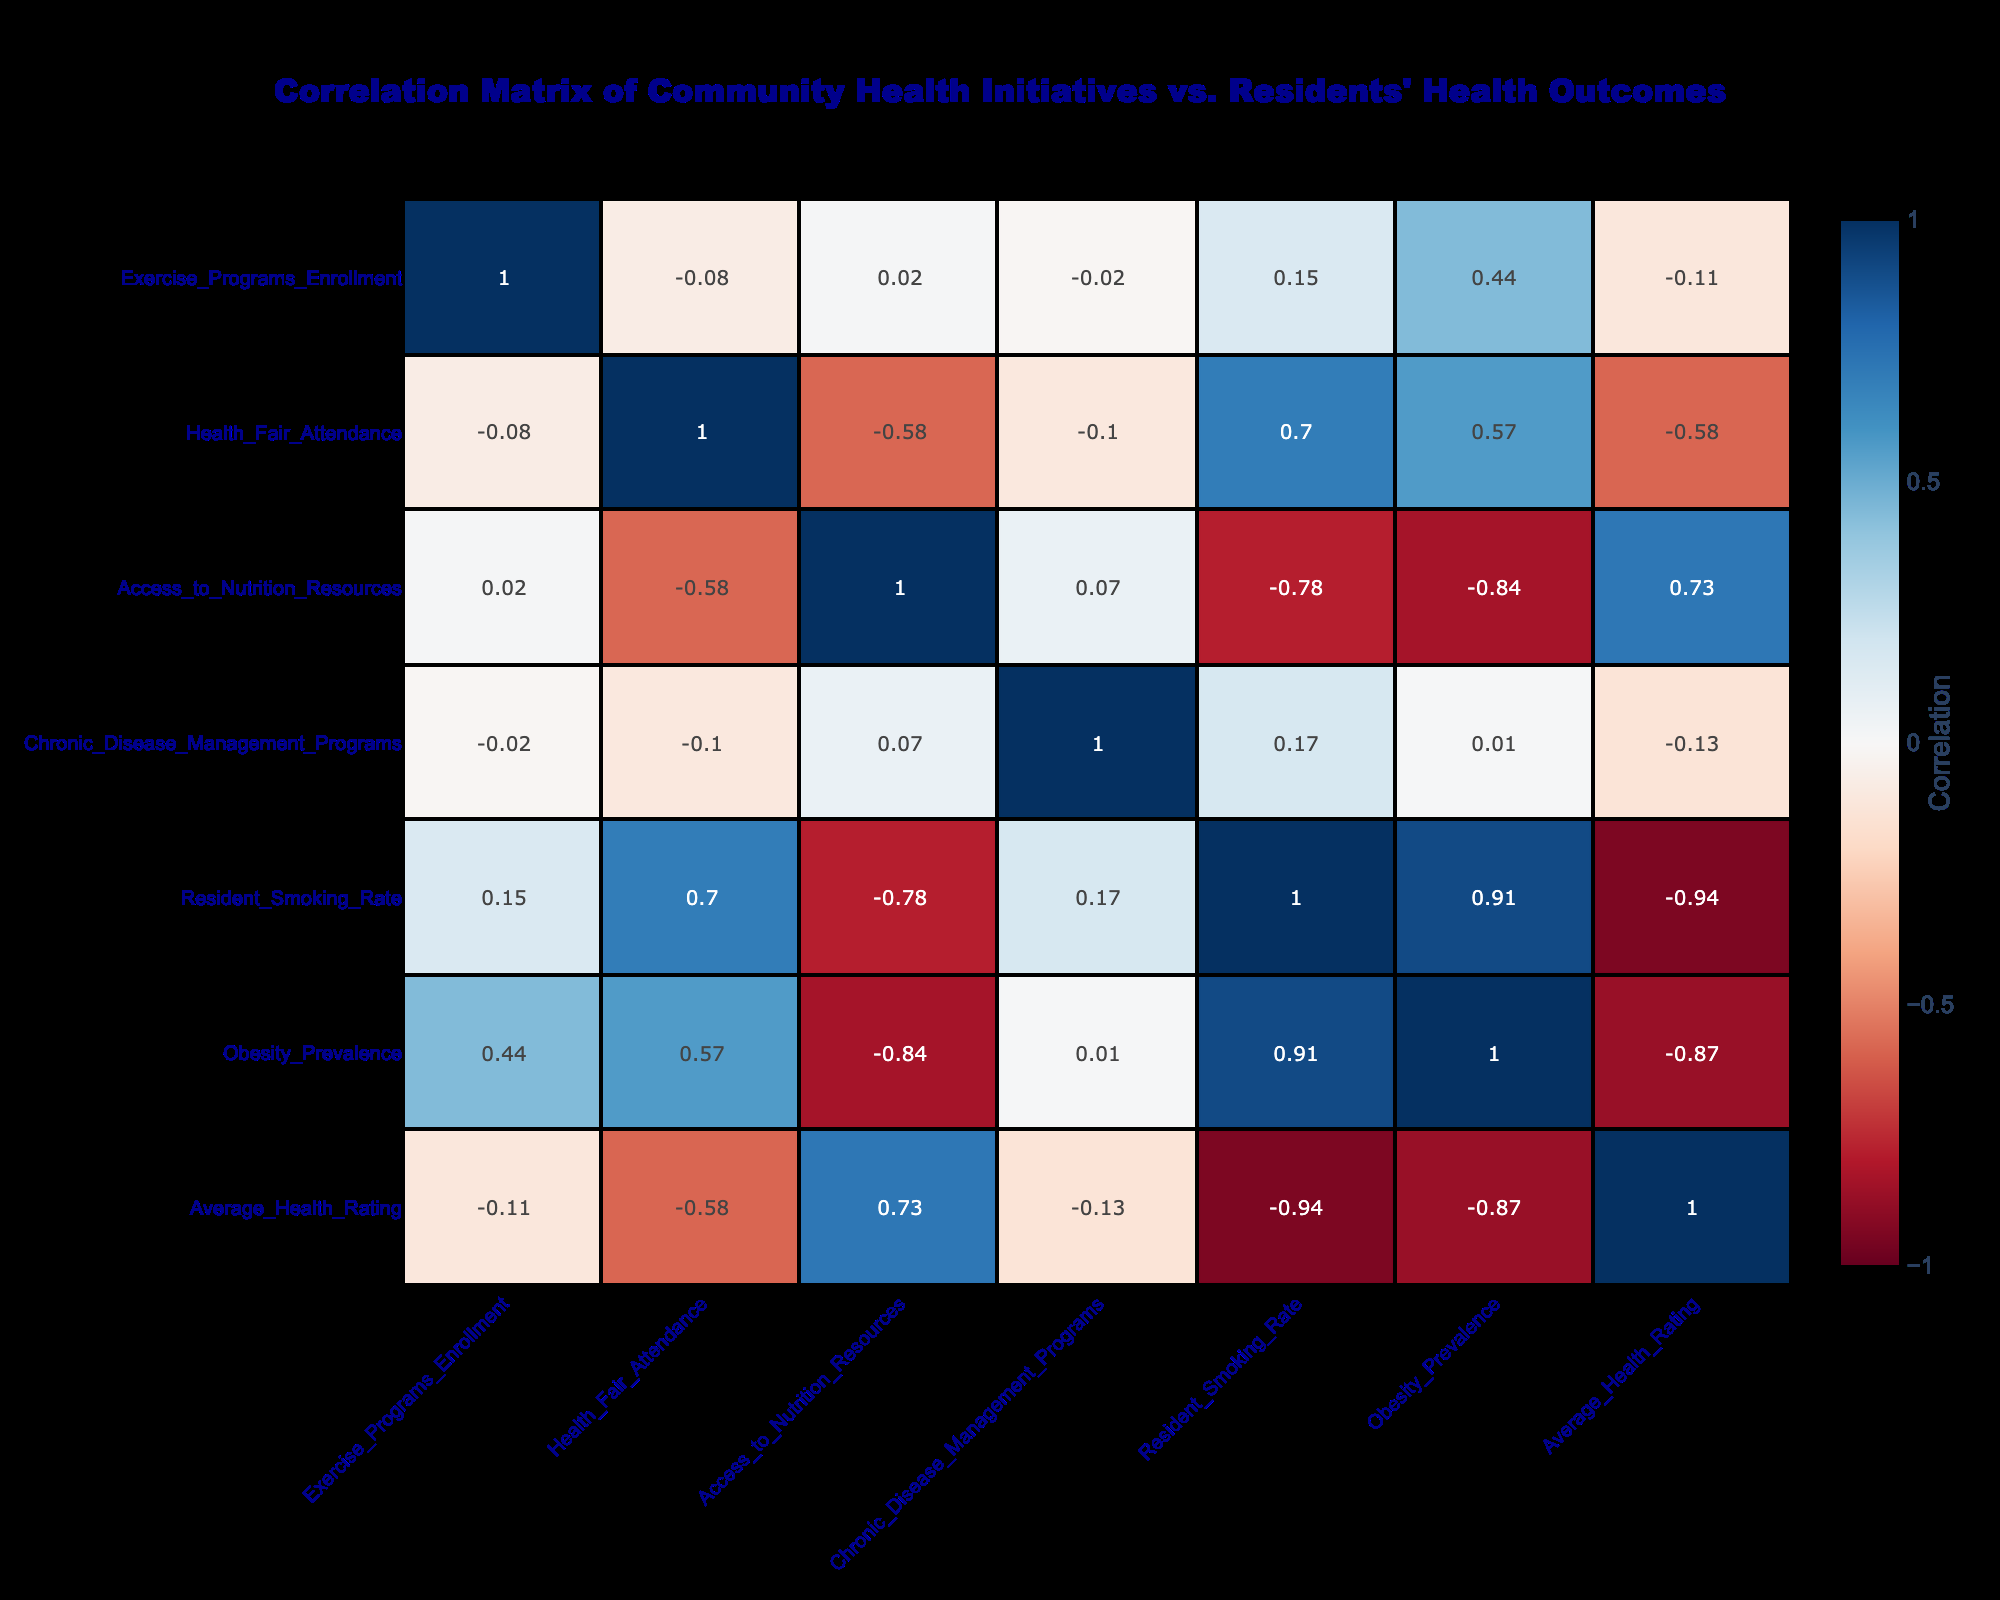What is the correlation between the Smoking Cessation Programs and the Resident Smoking Rate? Looking at the correlation table, the correlation coefficient between Smoking Cessation Programs and Resident Smoking Rate is -0.80, indicating a strong inverse relationship; as participation in cessation programs increases, the smoking rate tends to decrease.
Answer: -0.80 Which initiative correlates most positively with residents' average health rating? First, I will look through the correlation values relating to Average Health Rating. The initiative with the highest positive correlation (0.88) is the Smoking Cessation Programs, indicating that higher enrollment in these programs is associated with better average health ratings among residents.
Answer: Smoking Cessation Programs Are there any community health initiatives with a negative correlation with Obesity Prevalence? The table shows that both Nutrition Education Workshops (correlation of -0.84) and Smoking Cessation Programs (correlation of -0.70) have negative correlations with Obesity Prevalence, suggesting that as participation in these initiatives increases, obesity rates tend to decrease.
Answer: Yes What is the average correlation value of Exercise Programs Enrollment with all other health outcomes? To find the average correlation, we total the correlation values of Exercise Programs Enrollment with each of the resident health outcomes (0.50, 0.43, -0.80, -0.28, 0.40, 0.30) which sums up to 0.55, and divide it by the number of outcomes (6). Thus, the average correlation is 0.55 / 6 = 0.09167, rounded to approximately 0.09.
Answer: 0.09 Is there a significant correlation between Access to Nutrition Resources and the Average Health Rating? Yes, the correlation value between Access to Nutrition Resources and Average Health Rating is 0.69, indicating a strong positive relationship; more access to nutrition resources is associated with higher average health ratings.
Answer: Yes 